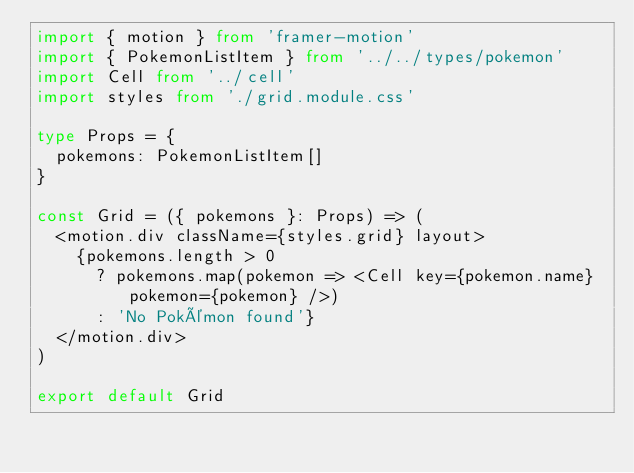<code> <loc_0><loc_0><loc_500><loc_500><_TypeScript_>import { motion } from 'framer-motion'
import { PokemonListItem } from '../../types/pokemon'
import Cell from '../cell'
import styles from './grid.module.css'

type Props = {
  pokemons: PokemonListItem[]
}

const Grid = ({ pokemons }: Props) => (
  <motion.div className={styles.grid} layout>
    {pokemons.length > 0
      ? pokemons.map(pokemon => <Cell key={pokemon.name} pokemon={pokemon} />)
      : 'No Pokémon found'}
  </motion.div>
)

export default Grid
</code> 